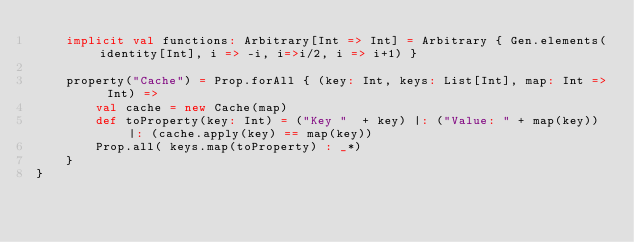Convert code to text. <code><loc_0><loc_0><loc_500><loc_500><_Scala_>	implicit val functions: Arbitrary[Int => Int] = Arbitrary { Gen.elements(identity[Int], i => -i, i=>i/2, i => i+1) }

	property("Cache") = Prop.forAll { (key: Int, keys: List[Int], map: Int => Int) =>
		val cache = new Cache(map)
		def toProperty(key: Int) = ("Key "  + key) |: ("Value: " + map(key)) |: (cache.apply(key) == map(key))
		Prop.all( keys.map(toProperty) : _*)
	}
}</code> 